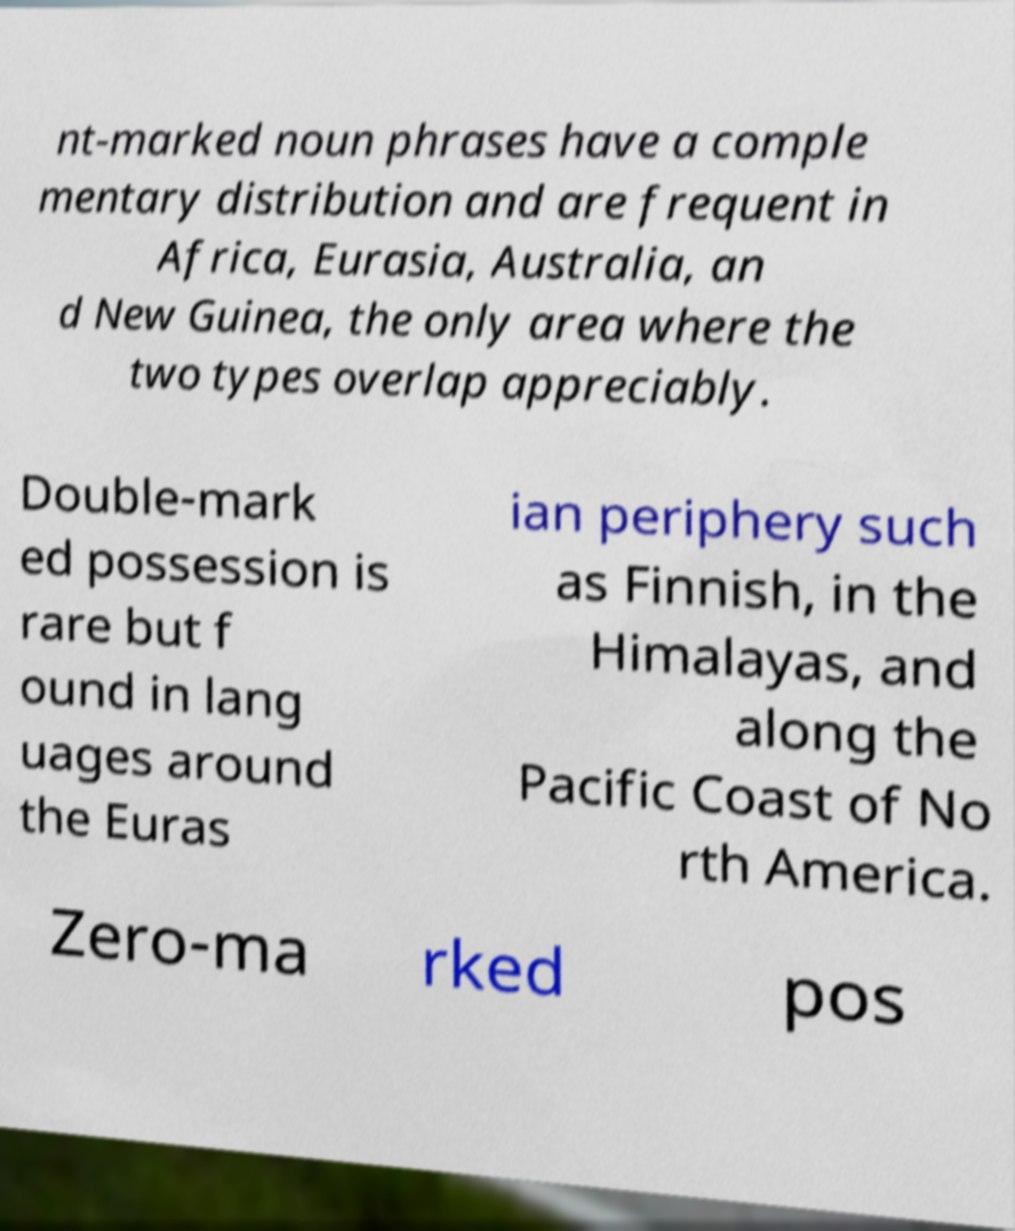Please identify and transcribe the text found in this image. nt-marked noun phrases have a comple mentary distribution and are frequent in Africa, Eurasia, Australia, an d New Guinea, the only area where the two types overlap appreciably. Double-mark ed possession is rare but f ound in lang uages around the Euras ian periphery such as Finnish, in the Himalayas, and along the Pacific Coast of No rth America. Zero-ma rked pos 